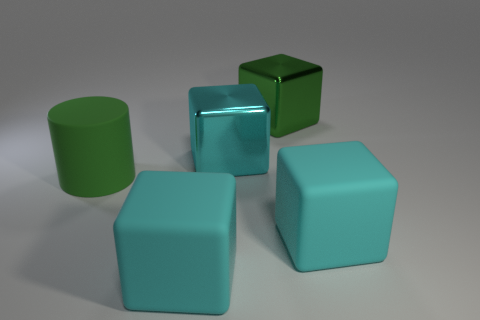How many cyan cubes must be subtracted to get 1 cyan cubes? 2 Subtract all green cylinders. How many cyan cubes are left? 3 Add 5 cyan rubber blocks. How many objects exist? 10 Subtract all red cubes. Subtract all purple balls. How many cubes are left? 4 Subtract 0 yellow blocks. How many objects are left? 5 Subtract all blocks. How many objects are left? 1 Subtract all cyan metal blocks. Subtract all large matte cubes. How many objects are left? 2 Add 1 cyan matte cubes. How many cyan matte cubes are left? 3 Add 1 large rubber cylinders. How many large rubber cylinders exist? 2 